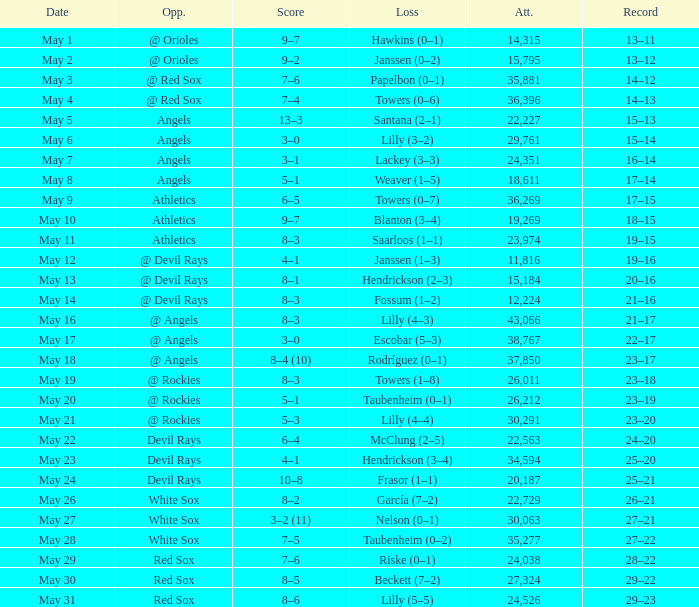When the team had their record of 16–14, what was the total attendance? 1.0. 